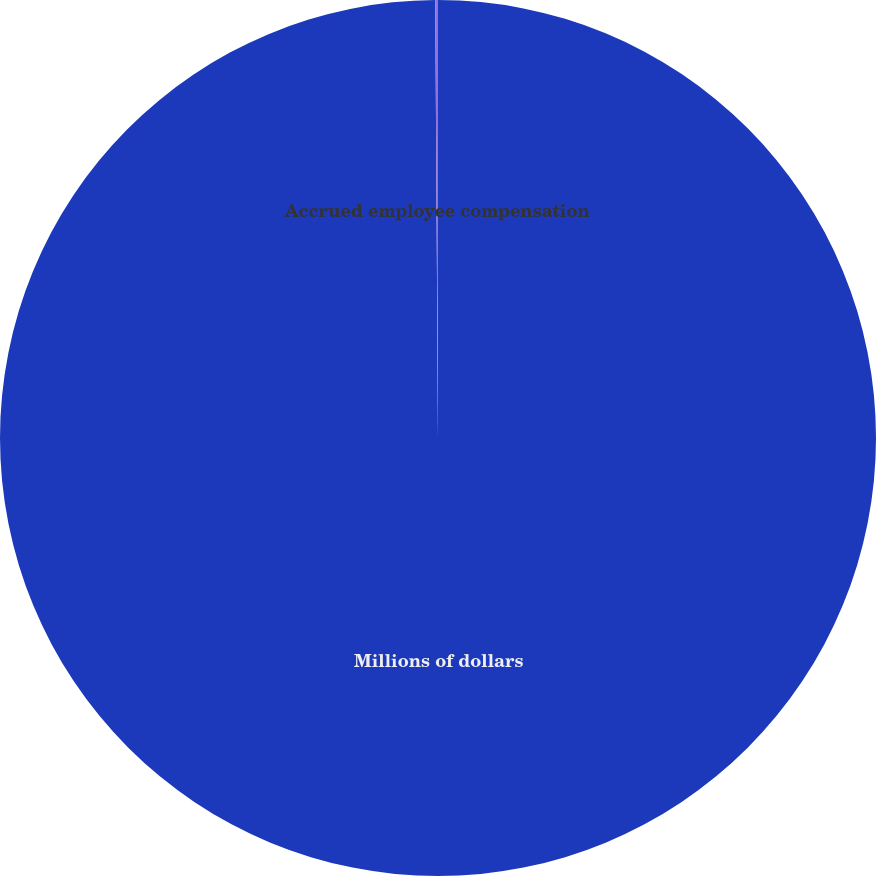Convert chart to OTSL. <chart><loc_0><loc_0><loc_500><loc_500><pie_chart><fcel>Millions of dollars<fcel>Accrued employee compensation<nl><fcel>99.9%<fcel>0.1%<nl></chart> 